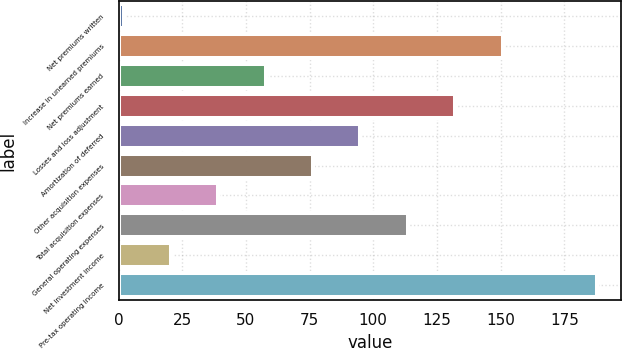Convert chart to OTSL. <chart><loc_0><loc_0><loc_500><loc_500><bar_chart><fcel>Net premiums written<fcel>Increase in unearned premiums<fcel>Net premiums earned<fcel>Losses and loss adjustment<fcel>Amortization of deferred<fcel>Other acquisition expenses<fcel>Total acquisition expenses<fcel>General operating expenses<fcel>Net investment income<fcel>Pre-tax operating income<nl><fcel>2<fcel>150.8<fcel>57.8<fcel>132.2<fcel>95<fcel>76.4<fcel>39.2<fcel>113.6<fcel>20.6<fcel>188<nl></chart> 